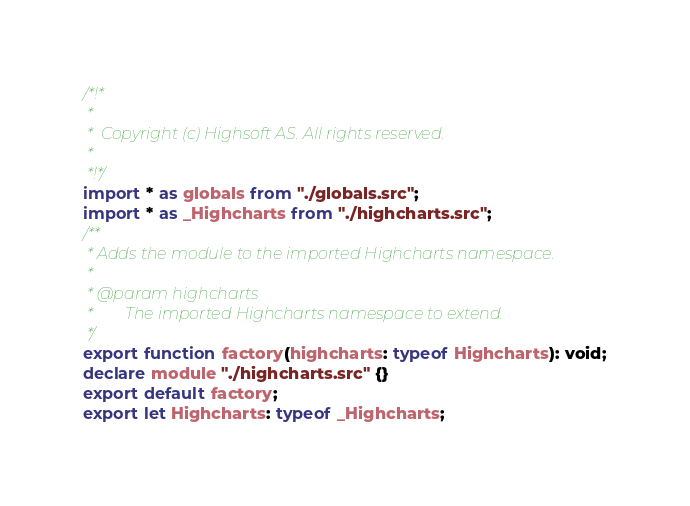Convert code to text. <code><loc_0><loc_0><loc_500><loc_500><_TypeScript_>/*!*
 *
 *  Copyright (c) Highsoft AS. All rights reserved.
 *
 *!*/
import * as globals from "./globals.src";
import * as _Highcharts from "./highcharts.src";
/**
 * Adds the module to the imported Highcharts namespace.
 *
 * @param highcharts
 *        The imported Highcharts namespace to extend.
 */
export function factory(highcharts: typeof Highcharts): void;
declare module "./highcharts.src" {}
export default factory;
export let Highcharts: typeof _Highcharts;
</code> 